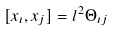<formula> <loc_0><loc_0><loc_500><loc_500>[ x _ { \imath } , x _ { j } ] = l ^ { 2 } \Theta _ { \imath j }</formula> 